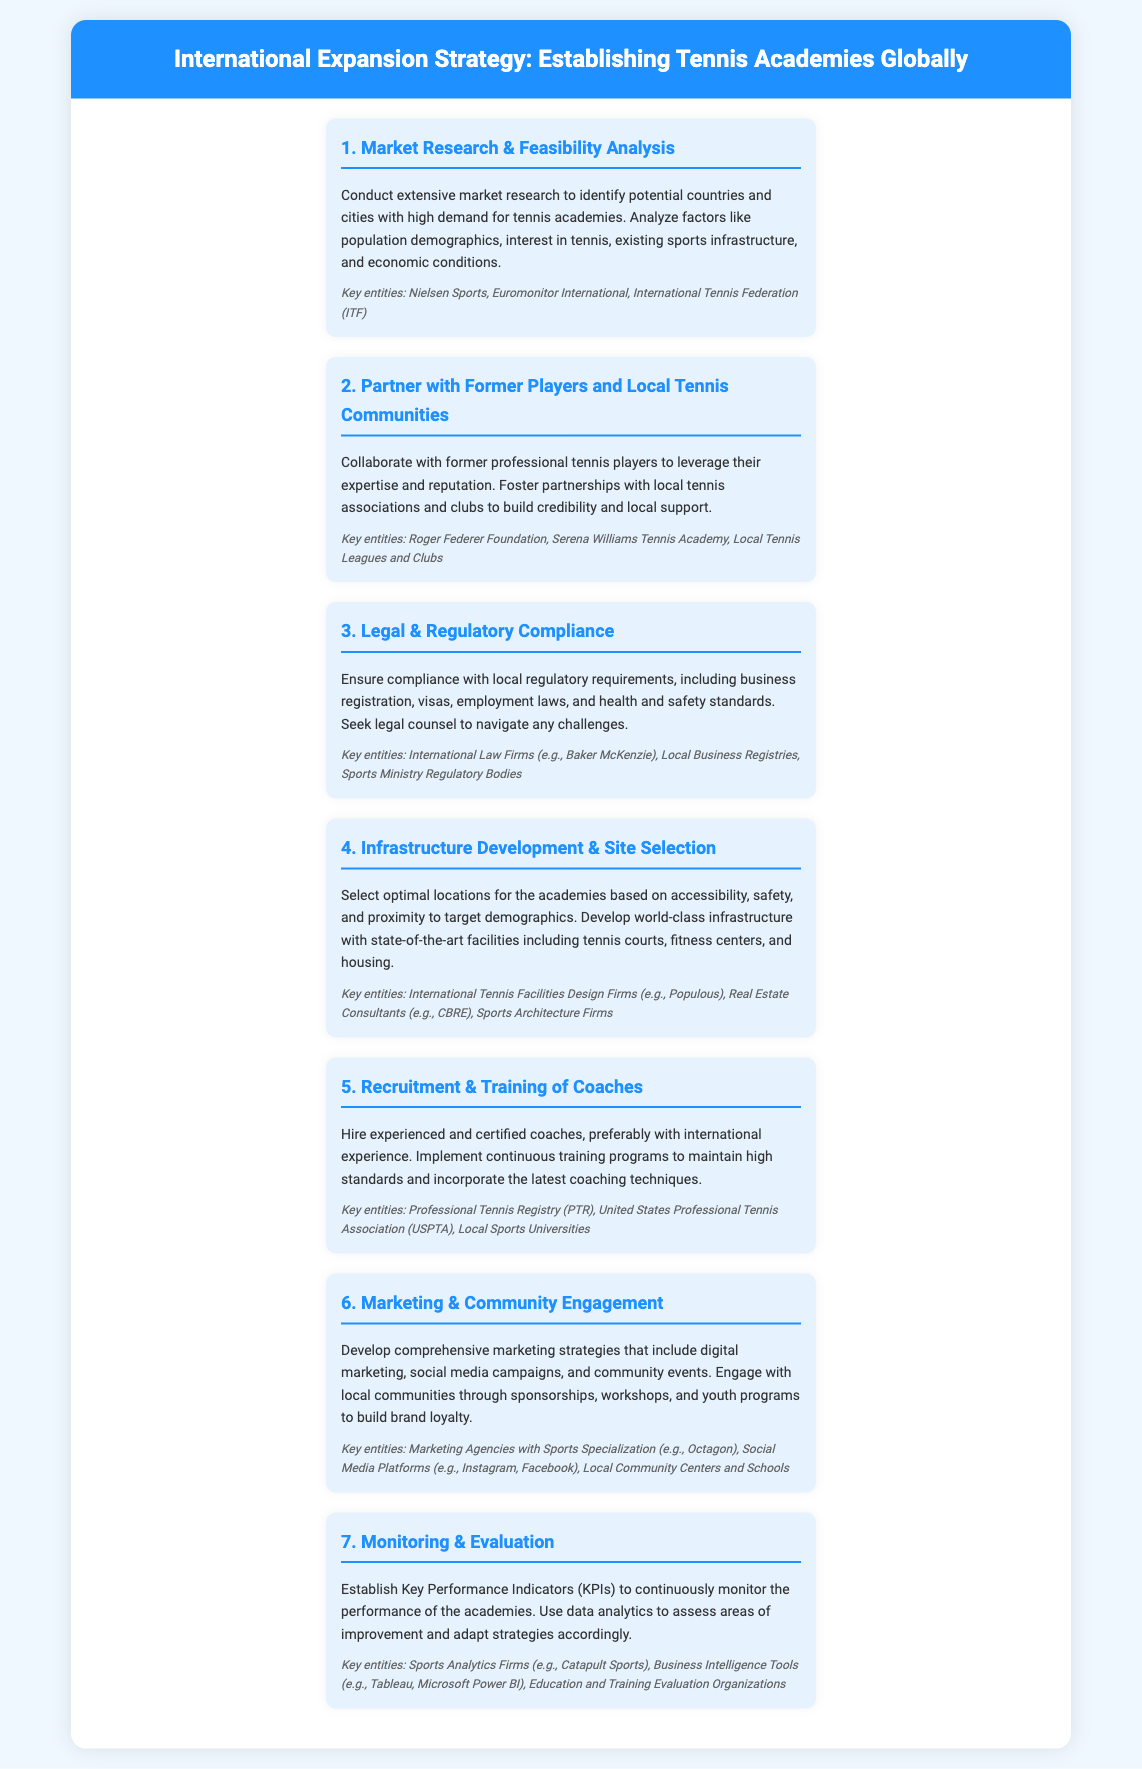What is the first step in the process? The first step outlined in the infographic is "Market Research & Feasibility Analysis."
Answer: Market Research & Feasibility Analysis Which key entity is mentioned for legal compliance? The document mentions "Baker McKenzie" as a key entity for legal compliance.
Answer: Baker McKenzie What is the primary focus of step 6? Step 6 focuses on marketing strategies and community engagement.
Answer: Marketing & Community Engagement How many key entities are listed under the recruitment of coaches? The document lists three key entities related to the recruitment of coaches.
Answer: Three What is a crucial aspect of step 5? A crucial aspect of step 5 is the hiring of experienced and certified coaches.
Answer: Hiring experienced and certified coaches Which regulatory body is mentioned for compliance? The document refers to "Sports Ministry Regulatory Bodies" for compliance.
Answer: Sports Ministry Regulatory Bodies What is a method for evaluating the academies’ performance? The method for evaluating performance includes establishing Key Performance Indicators (KPIs).
Answer: Key Performance Indicators (KPIs) Which key entity is highlighted for marketing strategies? "Octagon" is specified as a marketing agency with sports specialization.
Answer: Octagon What should be considered in "Infrastructure Development & Site Selection"? Accessibility, safety, and proximity to target demographics should be considered.
Answer: Accessibility, safety, and proximity to target demographics 